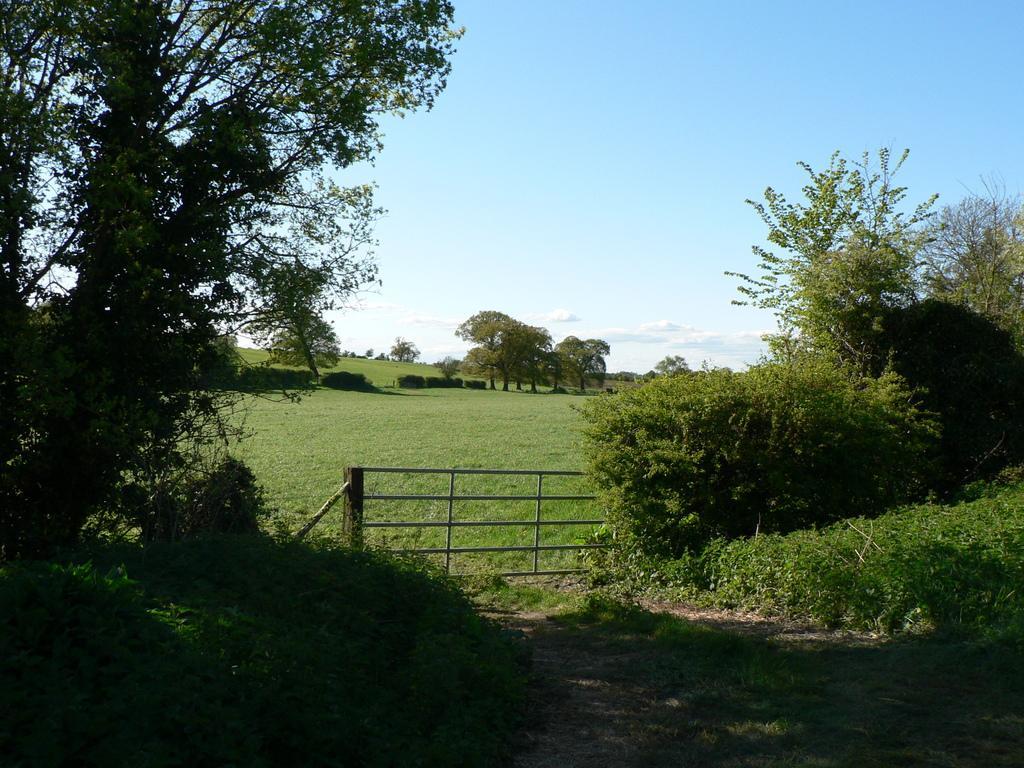How would you summarize this image in a sentence or two? In the center of the image there is a metal fence. At the bottom of the image there is grass on the surface. In the background of the image there are trees and sky. 